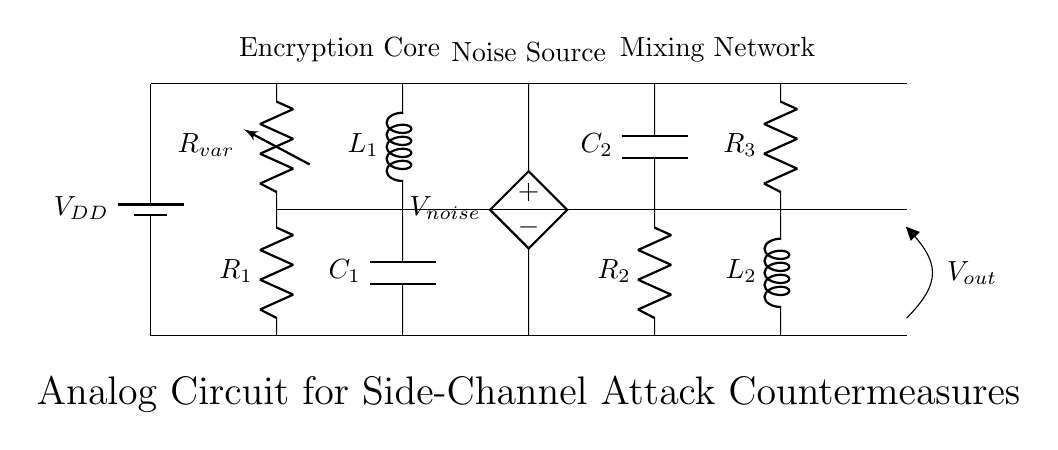What is the battery voltage in this circuit? The battery voltage is labeled as V DD, which is the supply voltage for the circuit components.
Answer: V DD What type of component is R var? R var is categorized as a variable resistor, indicated by the notation 'vR' in the diagram.
Answer: Variable resistor Which component is used to generate noise? The noise is generated by the component labeled V noise, which is an American controlled voltage source.
Answer: V noise How many resistors are present in the circuit? The circuit diagram shows three resistors: R1, R2, and R3. The total count can be found by simply counting them in the rendered diagram.
Answer: Three What is the role of the mixing network in this circuit? The mixing network combines signals from different sources to obscure the output, which is crucial in counteracting side-channel attacks.
Answer: To obscure output What happens to the output voltage when the variable resistor is adjusted? Adjusting the variable resistor R var influences the current flow and voltage drop across it, thereby affecting the output voltage V out as a countermeasure for side-channel attacks.
Answer: It changes the output voltage 